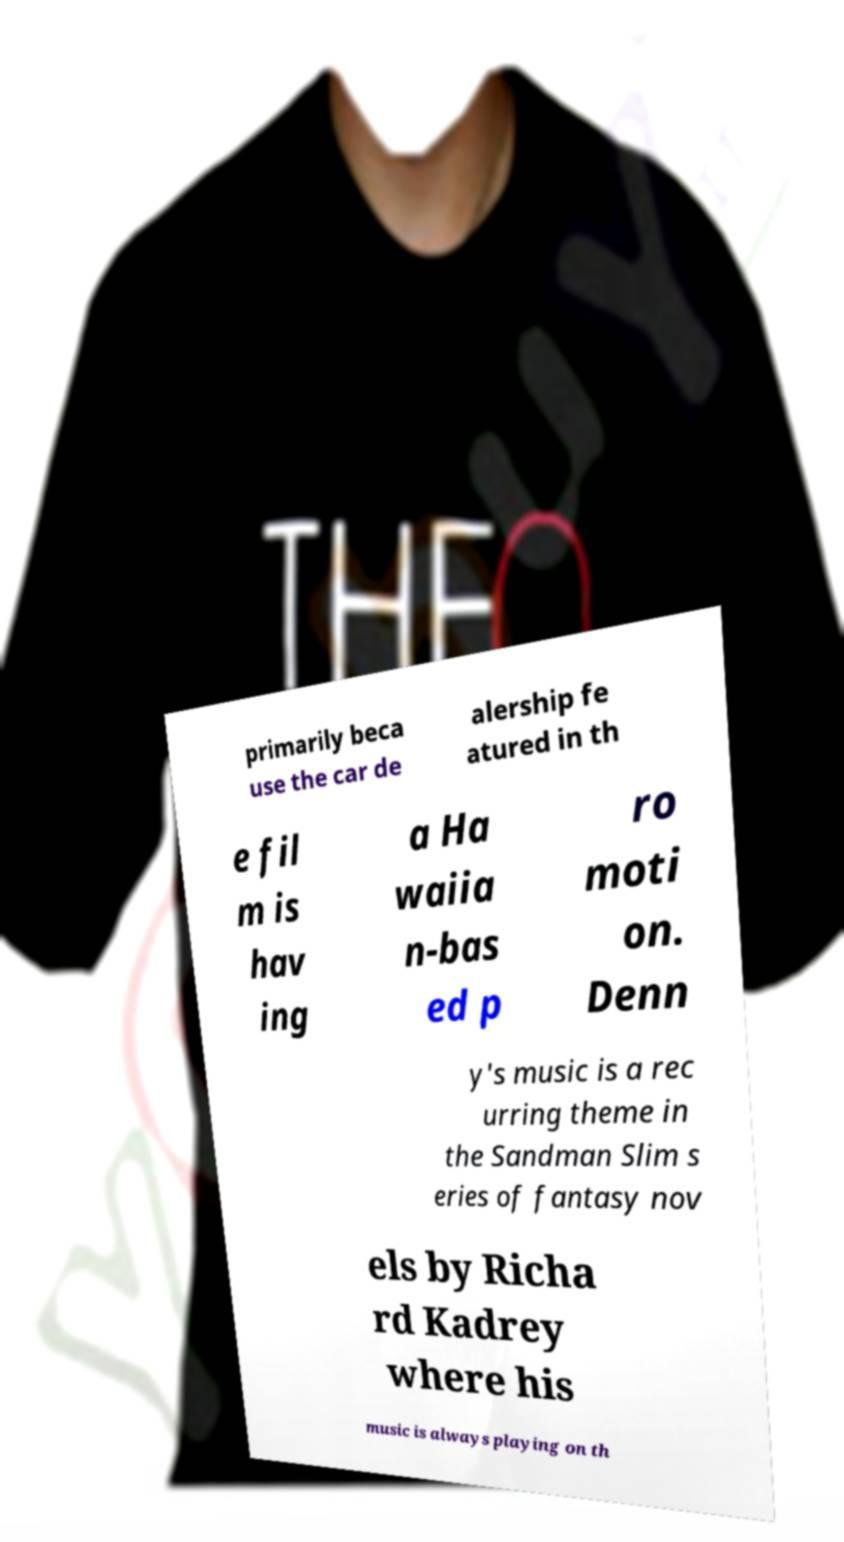What messages or text are displayed in this image? I need them in a readable, typed format. primarily beca use the car de alership fe atured in th e fil m is hav ing a Ha waiia n-bas ed p ro moti on. Denn y's music is a rec urring theme in the Sandman Slim s eries of fantasy nov els by Richa rd Kadrey where his music is always playing on th 